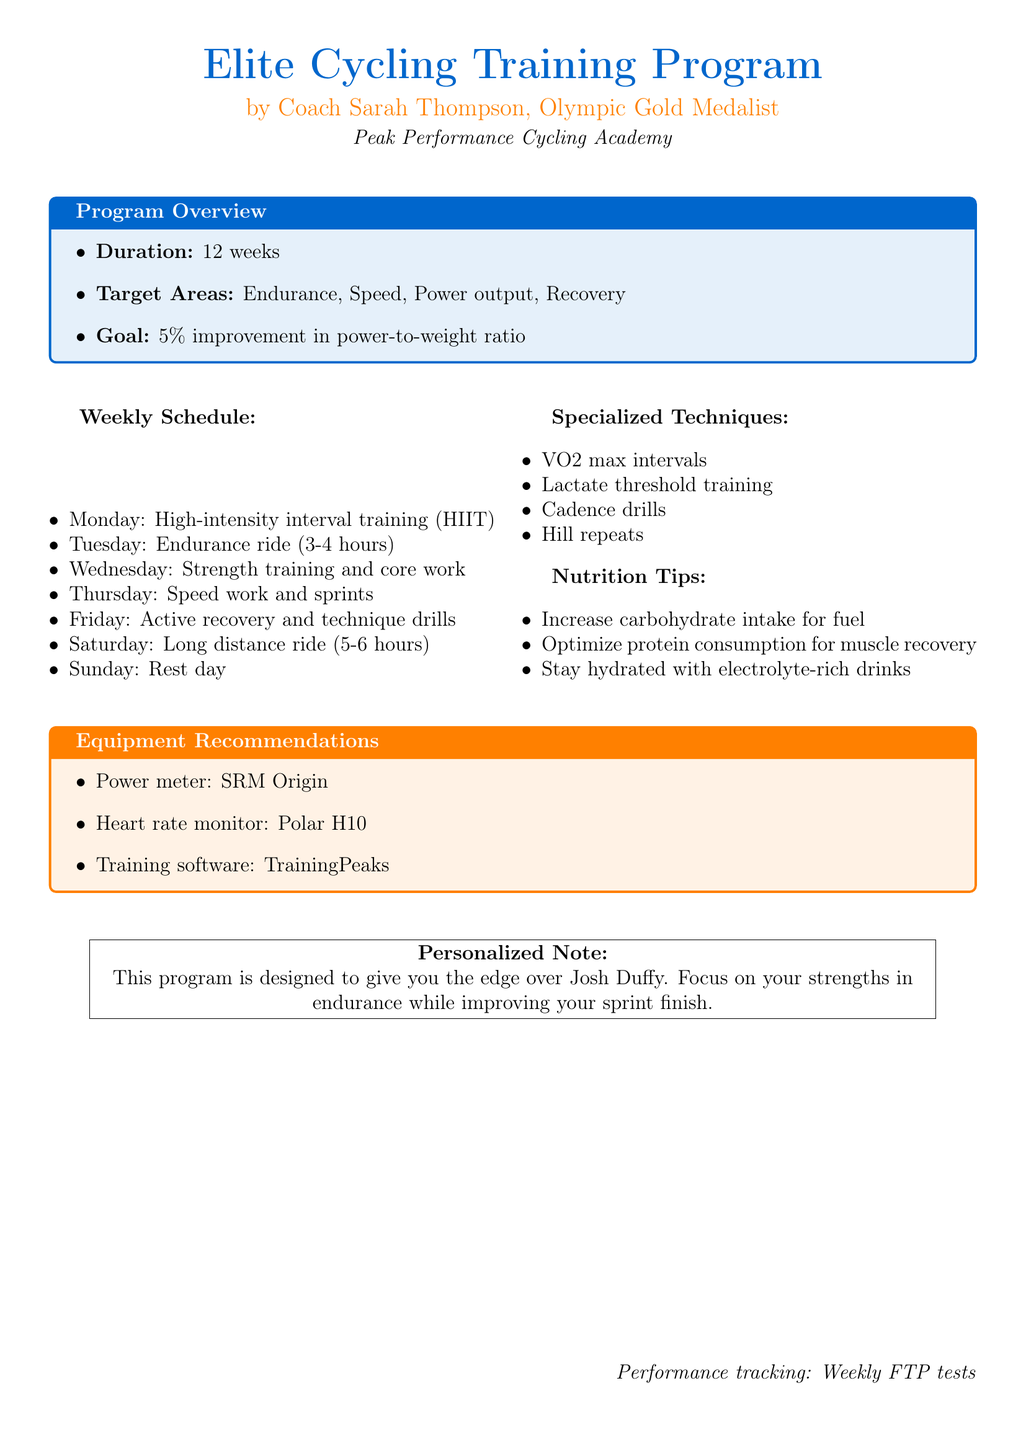What is the duration of the program? The program duration is explicitly stated in the document.
Answer: 12 weeks What is the goal of the training program? The goal of the program is mentioned directly in the overview section.
Answer: 5% improvement in power-to-weight ratio What day is designated for long distance rides? The document lists the activities for each day, which specifies long distance rides on a specific day.
Answer: Saturday What type of training is performed on Tuesday? The document describes the training activities for each day, showing the specific training done on Tuesday.
Answer: Endurance ride What specialized technique focuses on maximum oxygen uptake? The specialized techniques section includes a technique specifically named for that purpose.
Answer: VO2 max intervals What is recommended for muscle recovery? The nutrition tips section provides specific guidance on recovery nutrition.
Answer: Optimize protein consumption What equipment is recommended for tracking heart rate? The equipment recommendations section lists specific tools, including one for heart rate tracking.
Answer: Polar H10 What is the purpose of the personalized note? The personalized note clearly states its objective regarding performance in relation to another cyclist.
Answer: Give you the edge over Josh Duffy What is tracked weekly as part of performance monitoring? The document includes a specific mention of tracking that occurs on a weekly basis.
Answer: FTP tests 